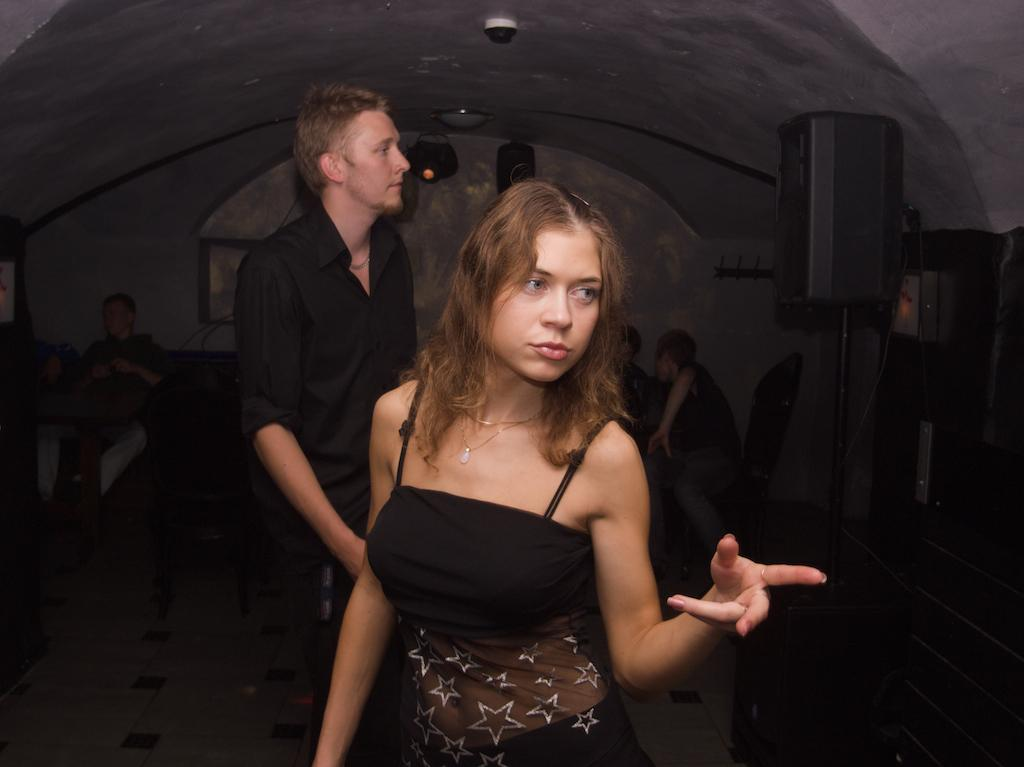Who is the main subject in the image? There is a woman in the image. What is the woman doing in the image? The woman is pointing to the right side of the image. What can be seen in the background of the image? There are people, light, a wall, a speaker, and unspecified things in the background of the image. What type of wine is being served by the monkey in the image? There is no monkey or wine present in the image. How does the woman stop the speaker from making noise in the image? The image does not show the woman stopping the speaker or any indication of noise. 